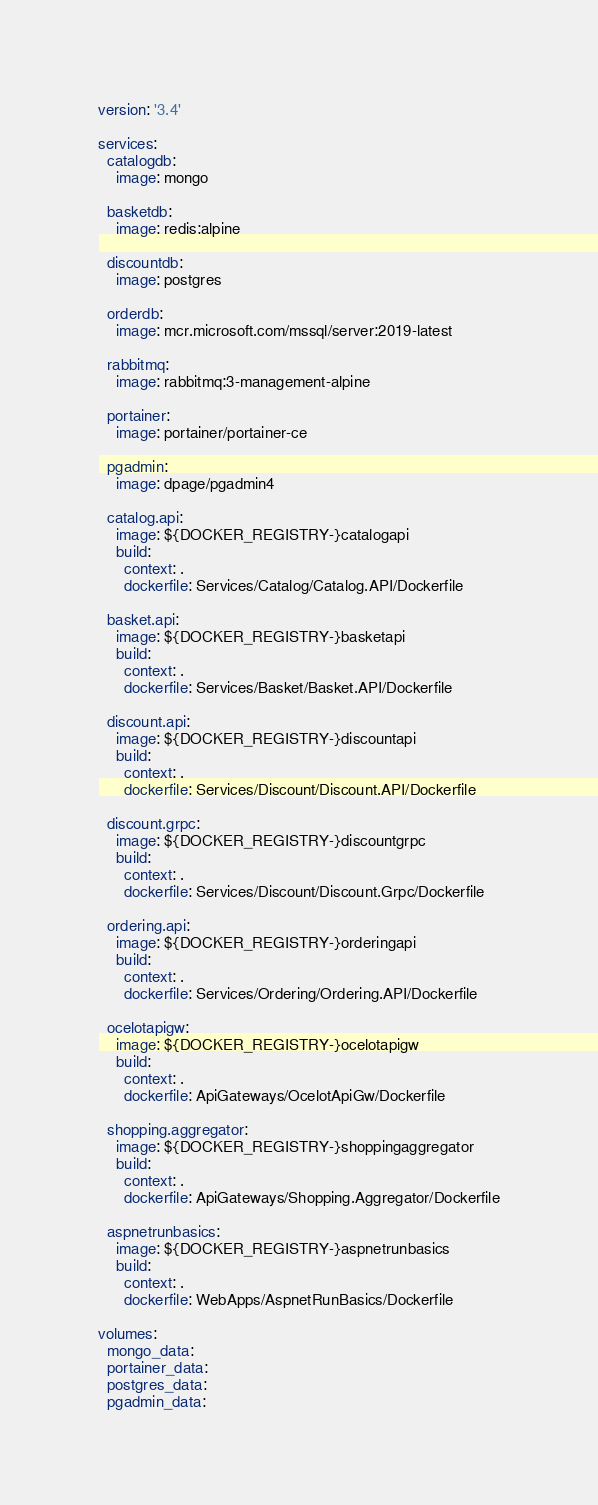<code> <loc_0><loc_0><loc_500><loc_500><_YAML_>version: '3.4'

services:
  catalogdb:
    image: mongo
  
  basketdb:
    image: redis:alpine

  discountdb:
    image: postgres

  orderdb:
    image: mcr.microsoft.com/mssql/server:2019-latest

  rabbitmq:
    image: rabbitmq:3-management-alpine

  portainer:
    image: portainer/portainer-ce

  pgadmin:
    image: dpage/pgadmin4

  catalog.api:
    image: ${DOCKER_REGISTRY-}catalogapi
    build:
      context: .
      dockerfile: Services/Catalog/Catalog.API/Dockerfile

  basket.api:
    image: ${DOCKER_REGISTRY-}basketapi
    build:
      context: .
      dockerfile: Services/Basket/Basket.API/Dockerfile

  discount.api:
    image: ${DOCKER_REGISTRY-}discountapi
    build:
      context: .
      dockerfile: Services/Discount/Discount.API/Dockerfile

  discount.grpc:
    image: ${DOCKER_REGISTRY-}discountgrpc
    build:
      context: .
      dockerfile: Services/Discount/Discount.Grpc/Dockerfile

  ordering.api:
    image: ${DOCKER_REGISTRY-}orderingapi
    build:
      context: .
      dockerfile: Services/Ordering/Ordering.API/Dockerfile

  ocelotapigw:
    image: ${DOCKER_REGISTRY-}ocelotapigw
    build:
      context: .
      dockerfile: ApiGateways/OcelotApiGw/Dockerfile

  shopping.aggregator:
    image: ${DOCKER_REGISTRY-}shoppingaggregator
    build:
      context: .
      dockerfile: ApiGateways/Shopping.Aggregator/Dockerfile

  aspnetrunbasics:
    image: ${DOCKER_REGISTRY-}aspnetrunbasics
    build:
      context: .
      dockerfile: WebApps/AspnetRunBasics/Dockerfile

volumes:
  mongo_data:
  portainer_data:
  postgres_data:
  pgadmin_data:







</code> 